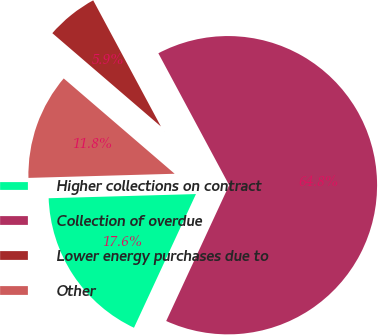Convert chart to OTSL. <chart><loc_0><loc_0><loc_500><loc_500><pie_chart><fcel>Higher collections on contract<fcel>Collection of overdue<fcel>Lower energy purchases due to<fcel>Other<nl><fcel>17.64%<fcel>64.75%<fcel>5.86%<fcel>11.75%<nl></chart> 